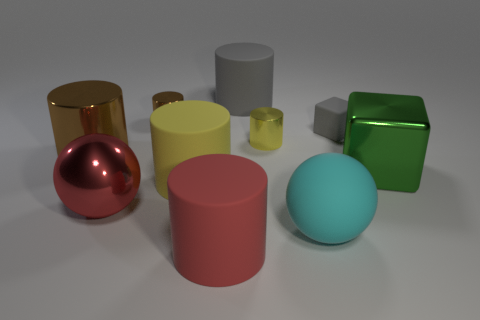Subtract 3 cylinders. How many cylinders are left? 3 Subtract all gray cylinders. How many cylinders are left? 5 Subtract all red rubber cylinders. How many cylinders are left? 5 Subtract all red cylinders. Subtract all purple balls. How many cylinders are left? 5 Subtract all cylinders. How many objects are left? 4 Subtract 0 red blocks. How many objects are left? 10 Subtract all large objects. Subtract all tiny shiny things. How many objects are left? 1 Add 7 tiny cylinders. How many tiny cylinders are left? 9 Add 9 green things. How many green things exist? 10 